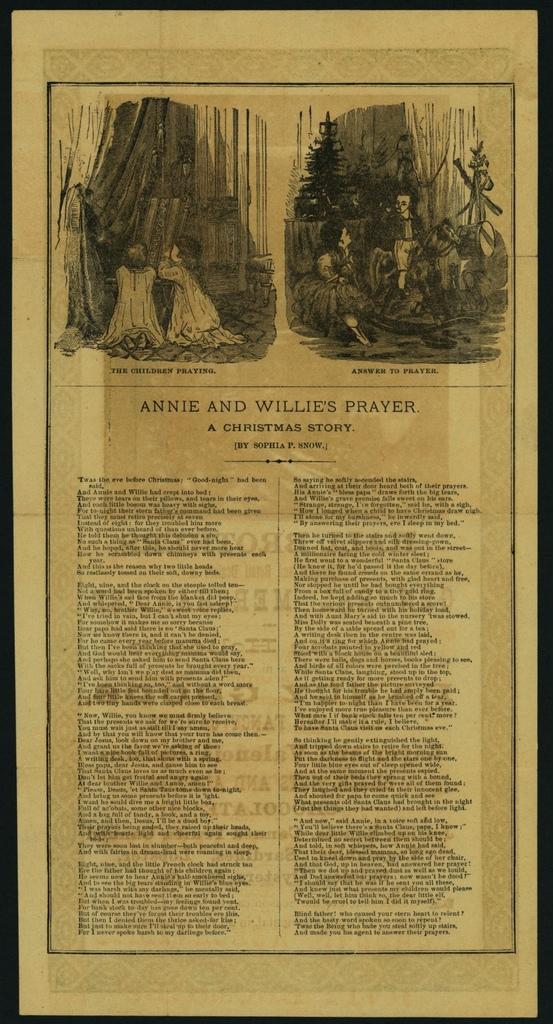How would you summarize this image in a sentence or two? In this picture I can see images and words on the paper. 